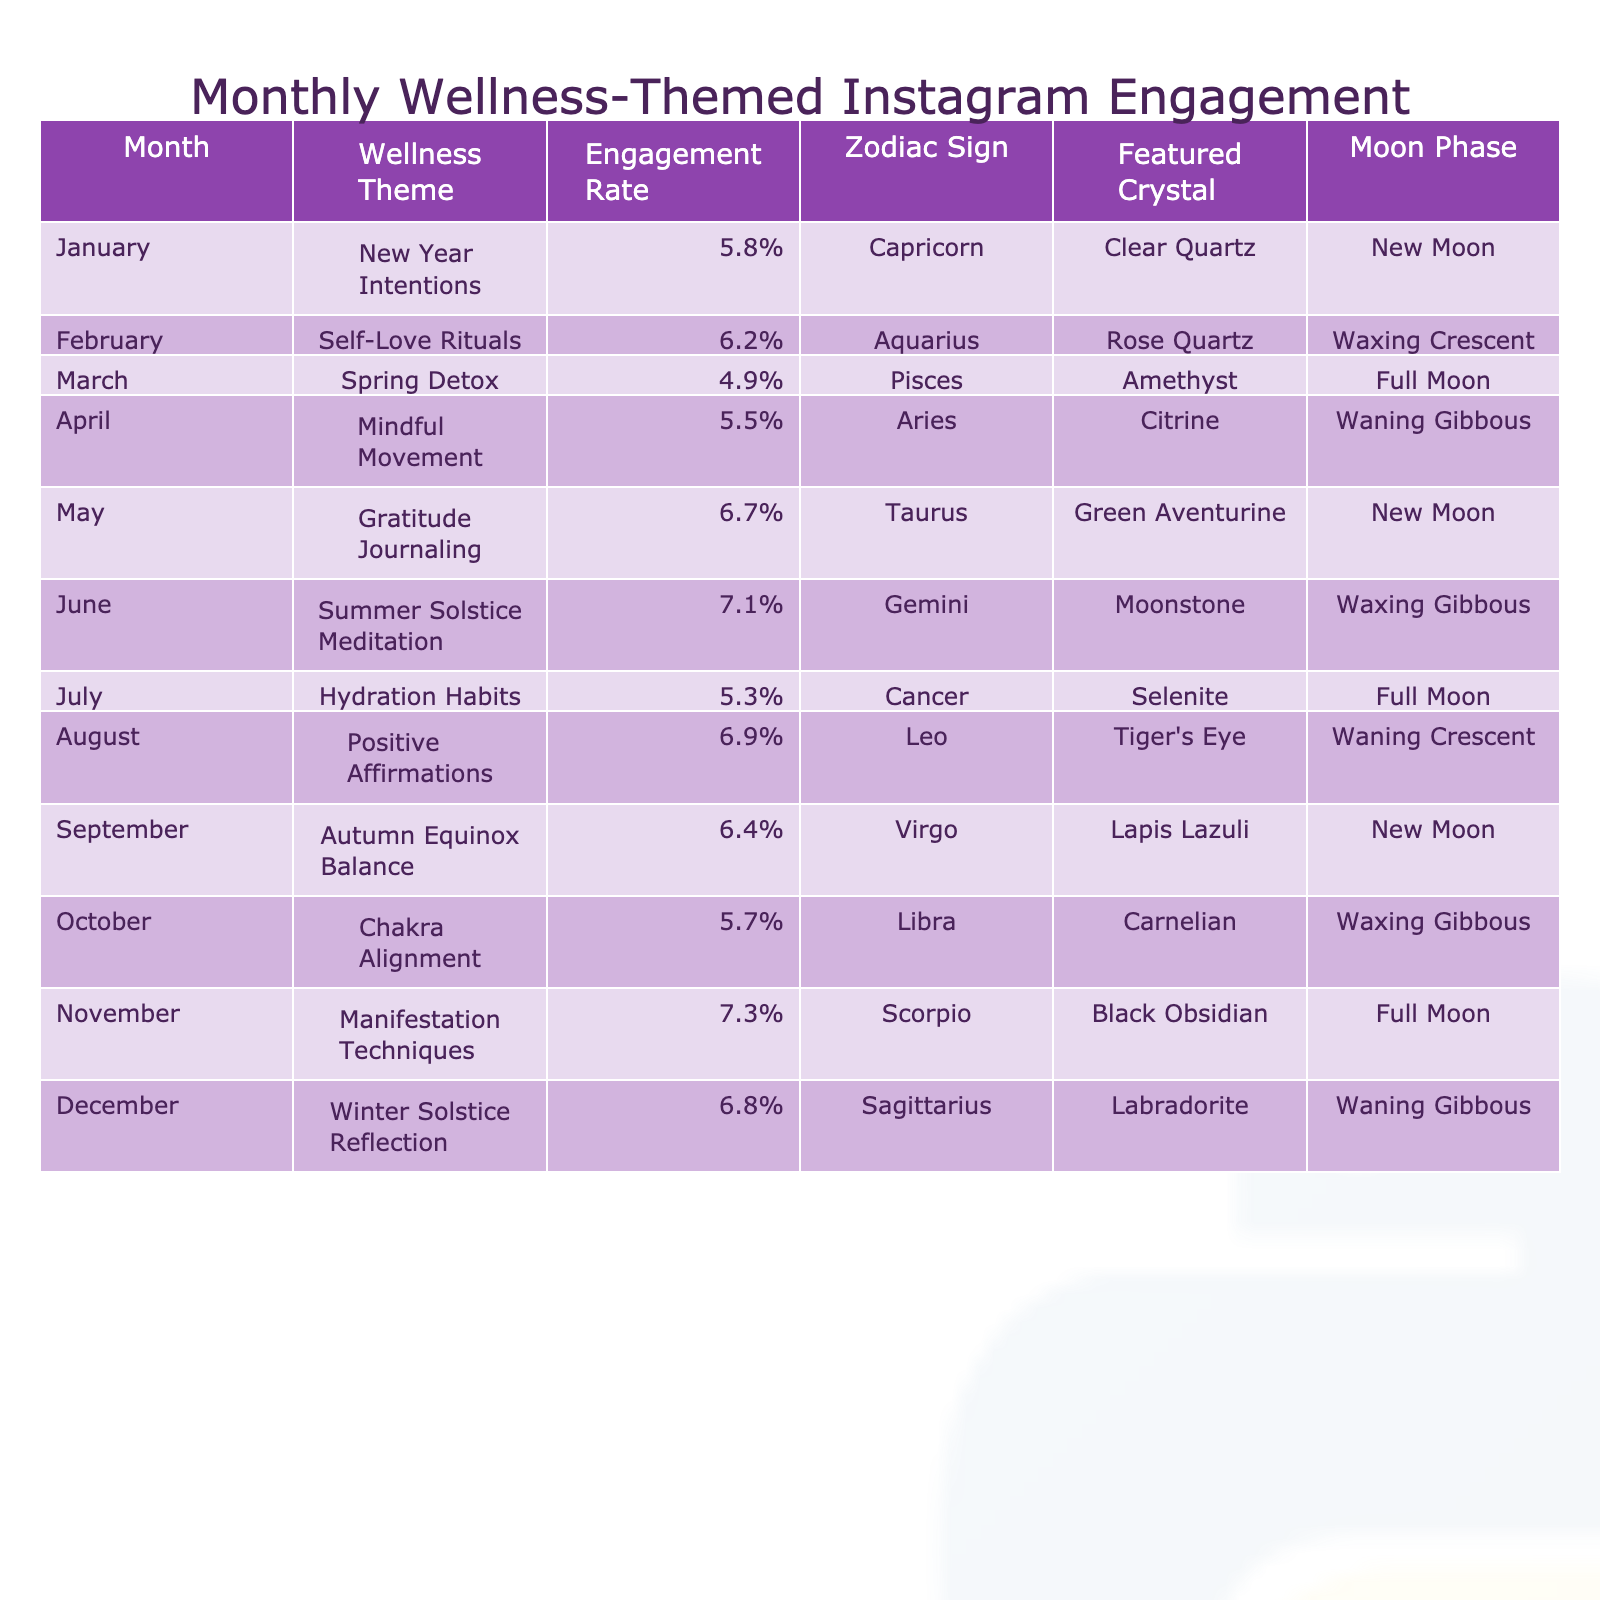What was the highest engagement rate for wellness-themed Instagram posts? The table shows the engagement rates for each month. The maximum value present is 7.3% in November for the theme "Manifestation Techniques."
Answer: 7.3% Which zodiac sign had a wellness theme with the lowest engagement rate? By reviewing the engagement rates, "Spring Detox" for Pisces had the lowest engagement rate at 4.9%.
Answer: Pisces What is the average engagement rate for wellness-themed posts from January to June? The engagement rates from January to June are: 5.8%, 6.2%, 4.9%, 5.5%, 6.7%, and 7.1%. Summing these rates gives 36.2%. Dividing by 6 months gives an average of 6.03%.
Answer: 6.03% Did any month feature both a "Full Moon" and a higher engagement rate than 6%? The table indicates that both June (7.1%) and November (7.3%) had a "Full Moon" phase and engagement rates exceeding 6%.
Answer: Yes Which wellness theme corresponds to the engagement rate closest to the average of all engagement rates listed? To find the average of all engagement rates: (5.8 + 6.2 + 4.9 + 5.5 + 6.7 + 7.1 + 5.3 + 6.9 + 6.4 + 5.7 + 7.3 + 6.8) / 12 = 6.28%. The themes closest to this value are "Autumn Equinox Balance" at 6.4% and "Winter Solstice Reflection" at 6.8%.
Answer: Autumn Equinox Balance and Winter Solstice Reflection What month had the highest engagement rate and which crystal was featured? The highest engagement rate is from November at 7.3%, with Black Obsidian as the featured crystal.
Answer: November, Black Obsidian Was there a wellness theme that had an engagement rate below 5%? Analyzing the table shows that all months had engagement rates above 4.9%. Thus, there are no themes below 5%.
Answer: No What is the difference in engagement rate between the "Summer Solstice Meditation" and "Gratitude Journaling" themes? The engagement rate for "Summer Solstice Meditation" in June is 7.1% and for "Gratitude Journaling" in May is 6.7%. The difference is 7.1% - 6.7% = 0.4%.
Answer: 0.4% 